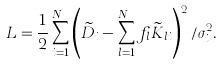<formula> <loc_0><loc_0><loc_500><loc_500>L = \frac { 1 } { 2 } \sum _ { i = 1 } ^ { N _ { D } } \left ( \widetilde { D } _ { i } - \sum _ { l = 1 } ^ { N _ { \omega } } f _ { l } \widetilde { K } _ { l i } \right ) ^ { 2 } / \sigma ^ { 2 } _ { i } .</formula> 